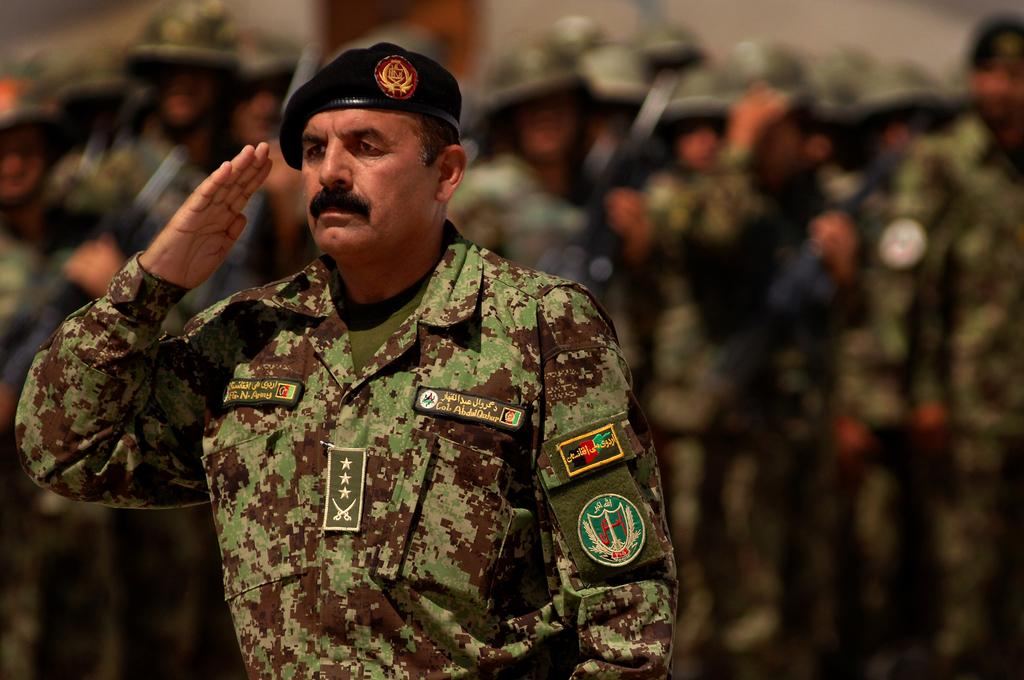What is the person in the image doing? The person in the image is standing and saluting. Are there any other people in the image? Yes, there are a few people standing behind the person in the image. What type of chair is the person sitting on in the image? There is no chair present in the image; the person is standing and saluting. Can you see any roses in the image? There are no roses visible in the image. 